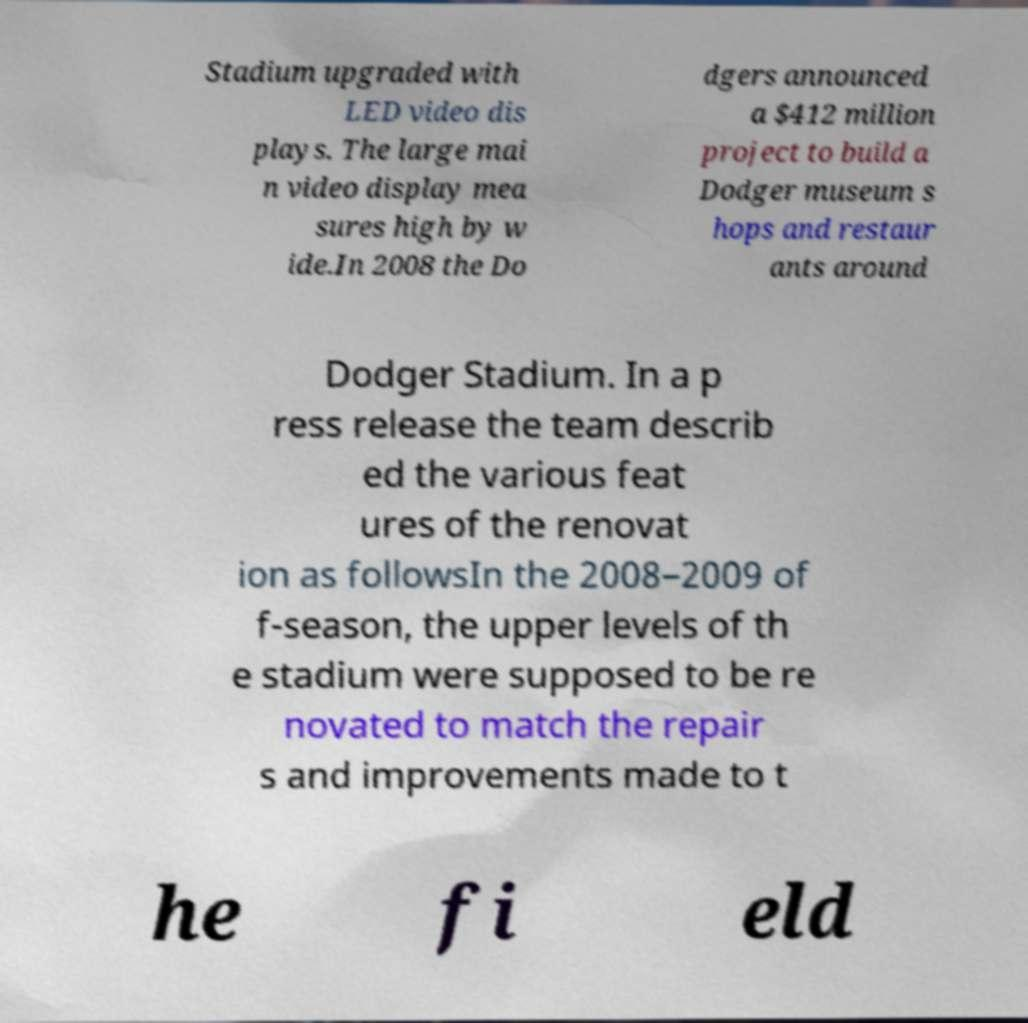Could you extract and type out the text from this image? Stadium upgraded with LED video dis plays. The large mai n video display mea sures high by w ide.In 2008 the Do dgers announced a $412 million project to build a Dodger museum s hops and restaur ants around Dodger Stadium. In a p ress release the team describ ed the various feat ures of the renovat ion as followsIn the 2008–2009 of f-season, the upper levels of th e stadium were supposed to be re novated to match the repair s and improvements made to t he fi eld 